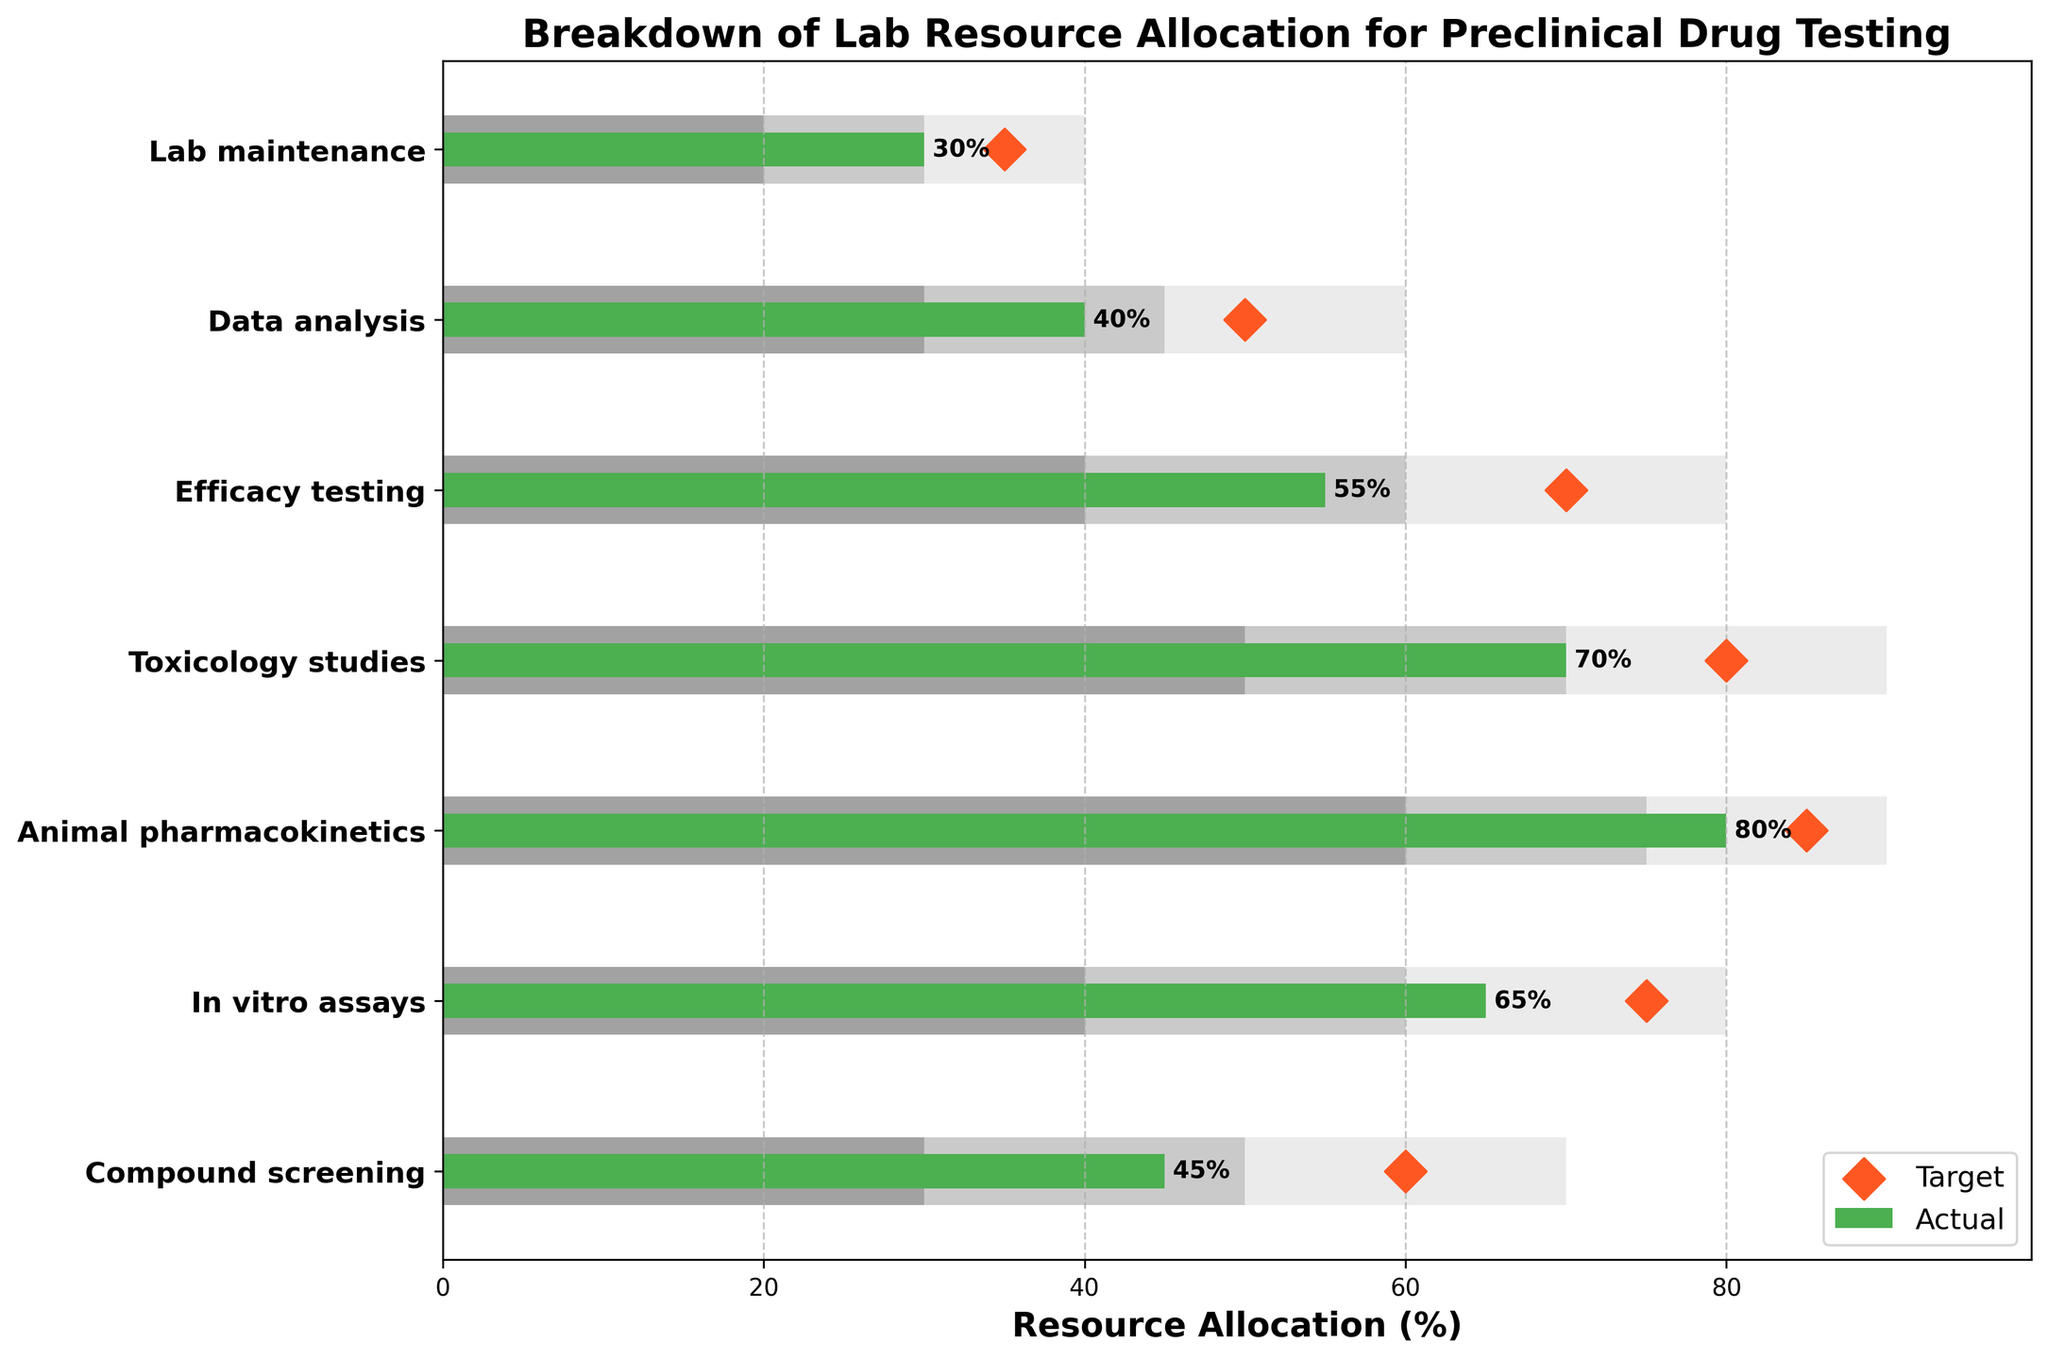Which category has the lowest actual resource allocation? The figure shows several categories with their respective resource allocation values. The category labeled "Lab maintenance" has the smallest green bar, indicating that it has the lowest actual resource allocation.
Answer: Lab maintenance What is the target resource allocation for Efficacy testing? The target allocation is represented by the diamond markers. For Efficacy Testing, the diamond marker is at 70.
Answer: 70 How much lower is the actual allocation for Compound screening compared to its target? Compare the actual allocation (green bar) and target allocation (diamond marker) for Compound Screening. The actual is 45, and the target is 60. The difference is 60 - 45 = 15.
Answer: 15 Which category has the actual resource allocation exceeding its Range1 limit? Identify the categories and compare the actual allocation (green bar) with the Range1 limit. The "Animal pharmacokinetics" category has 80 as its actual allocation, which exceeds its Range1 limit of 75.
Answer: Animal pharmacokinetics What's the average target resource allocation for all categories? Sum all target values and divide by the number of categories. (60 + 75 + 85 + 80 + 70 + 50 + 35) / 7 = 455 / 7 = 65.
Answer: 65 How many categories have their actual allocation below their respective Range1 limits? Compare the actual allocation values with their Range1 limits for each category. The categories where actual < Range1 are Compound screening, In vitro assays, Data analysis, Lab maintenance (4 categories).
Answer: 4 Which category has the highest discrepancy between actual and Range3 limits? Calculate the discrepancy for each category by subtracting the actual from the Range3 limit: 
Compound screening: 70 - 45 = 25
In vitro assays: 80 - 65 = 15
Animal pharmacokinetics: 90 - 80 = 10
Toxicology studies: 90 - 70 = 20
Efficacy testing: 80 - 55 = 25
Data analysis: 60 - 40 = 20
Lab maintenance: 40 - 30 = 10
Compound screening and Efficacy testing both have the largest discrepancy (25).
Answer: Compound screening and Efficacy testing What is the title of the chart? The title is located at the top of the figure and reads: "Breakdown of Lab Resource Allocation for Preclinical Drug Testing."
Answer: Breakdown of Lab Resource Allocation for Preclinical Drug Testing 